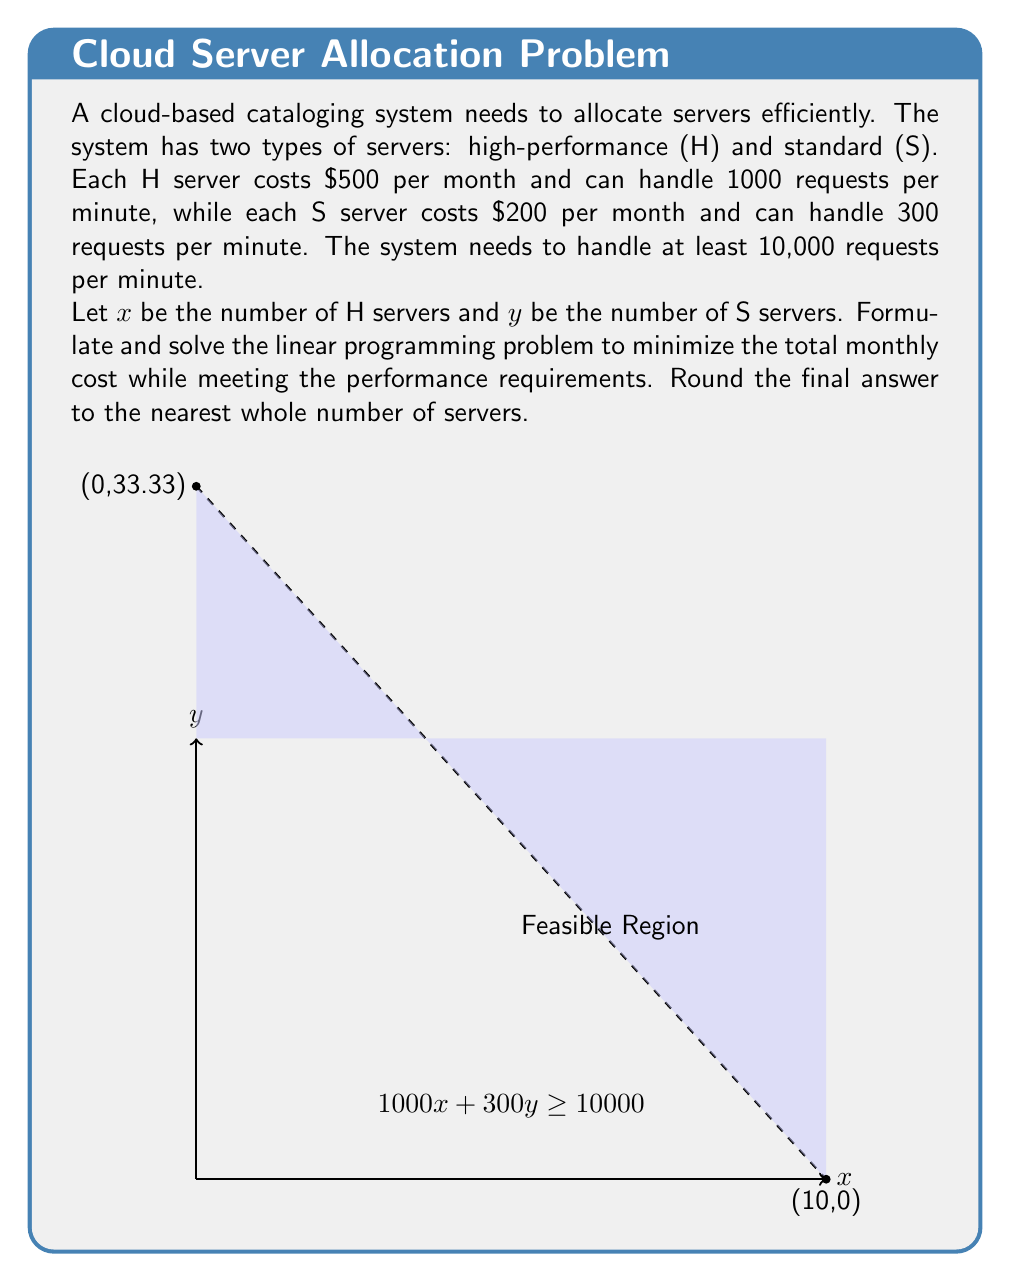Provide a solution to this math problem. Let's approach this step-by-step:

1) First, we need to formulate the objective function. We want to minimize the total cost:
   
   Minimize: $Z = 500x + 200y$

2) Now, we need to define the constraints:
   
   a) Performance constraint: $1000x + 300y \geq 10000$
   b) Non-negativity constraints: $x \geq 0$, $y \geq 0$

3) The linear programming problem is now:

   Minimize: $Z = 500x + 200y$
   Subject to:
   $1000x + 300y \geq 10000$
   $x \geq 0$, $y \geq 0$

4) To solve this, we can use the graphical method. The feasible region is shown in the graph.

5) The optimal solution will be at one of the corner points of the feasible region. The corner points are:
   (10, 0) and (0, 33.33)

6) Let's evaluate the objective function at these points:
   At (10, 0): $Z = 500(10) + 200(0) = 5000$
   At (0, 33.33): $Z = 500(0) + 200(33.33) = 6666$

7) The minimum cost is at (10, 0), which means 10 high-performance servers and 0 standard servers.

8) Rounding to the nearest whole number (which is already done in this case):
   10 high-performance servers, 0 standard servers
Answer: 10 H servers, 0 S servers 